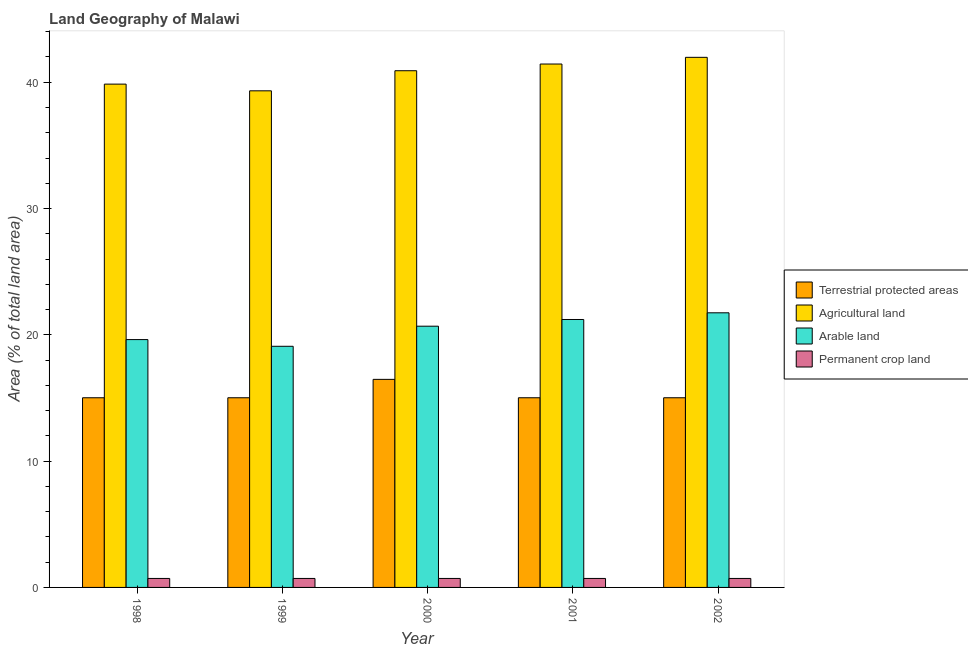How many different coloured bars are there?
Your response must be concise. 4. How many groups of bars are there?
Give a very brief answer. 5. Are the number of bars per tick equal to the number of legend labels?
Give a very brief answer. Yes. Are the number of bars on each tick of the X-axis equal?
Offer a terse response. Yes. How many bars are there on the 4th tick from the right?
Offer a very short reply. 4. What is the percentage of land under terrestrial protection in 1998?
Your answer should be compact. 15.02. Across all years, what is the maximum percentage of area under agricultural land?
Give a very brief answer. 41.97. Across all years, what is the minimum percentage of area under arable land?
Your answer should be compact. 19.09. In which year was the percentage of land under terrestrial protection maximum?
Your answer should be very brief. 2000. In which year was the percentage of area under agricultural land minimum?
Ensure brevity in your answer.  1999. What is the total percentage of area under permanent crop land in the graph?
Make the answer very short. 3.55. What is the difference between the percentage of area under agricultural land in 2000 and that in 2001?
Offer a terse response. -0.53. What is the difference between the percentage of area under permanent crop land in 1999 and the percentage of area under arable land in 2000?
Your answer should be compact. 0. What is the average percentage of land under terrestrial protection per year?
Offer a very short reply. 15.31. In how many years, is the percentage of area under agricultural land greater than 20 %?
Ensure brevity in your answer.  5. Is the difference between the percentage of land under terrestrial protection in 2000 and 2002 greater than the difference between the percentage of area under agricultural land in 2000 and 2002?
Provide a short and direct response. No. What is the difference between the highest and the second highest percentage of land under terrestrial protection?
Make the answer very short. 1.46. What is the difference between the highest and the lowest percentage of land under terrestrial protection?
Ensure brevity in your answer.  1.46. In how many years, is the percentage of land under terrestrial protection greater than the average percentage of land under terrestrial protection taken over all years?
Make the answer very short. 1. Is the sum of the percentage of area under agricultural land in 1998 and 2000 greater than the maximum percentage of land under terrestrial protection across all years?
Your answer should be very brief. Yes. What does the 4th bar from the left in 1999 represents?
Make the answer very short. Permanent crop land. What does the 4th bar from the right in 1998 represents?
Your answer should be very brief. Terrestrial protected areas. Are all the bars in the graph horizontal?
Ensure brevity in your answer.  No. Does the graph contain any zero values?
Offer a terse response. No. Where does the legend appear in the graph?
Offer a terse response. Center right. How many legend labels are there?
Your response must be concise. 4. How are the legend labels stacked?
Your answer should be compact. Vertical. What is the title of the graph?
Give a very brief answer. Land Geography of Malawi. Does "Other expenses" appear as one of the legend labels in the graph?
Ensure brevity in your answer.  No. What is the label or title of the Y-axis?
Keep it short and to the point. Area (% of total land area). What is the Area (% of total land area) in Terrestrial protected areas in 1998?
Provide a succinct answer. 15.02. What is the Area (% of total land area) in Agricultural land in 1998?
Give a very brief answer. 39.85. What is the Area (% of total land area) of Arable land in 1998?
Your response must be concise. 19.62. What is the Area (% of total land area) of Permanent crop land in 1998?
Your response must be concise. 0.71. What is the Area (% of total land area) in Terrestrial protected areas in 1999?
Provide a short and direct response. 15.02. What is the Area (% of total land area) in Agricultural land in 1999?
Provide a short and direct response. 39.32. What is the Area (% of total land area) of Arable land in 1999?
Your answer should be compact. 19.09. What is the Area (% of total land area) of Permanent crop land in 1999?
Offer a terse response. 0.71. What is the Area (% of total land area) of Terrestrial protected areas in 2000?
Give a very brief answer. 16.47. What is the Area (% of total land area) of Agricultural land in 2000?
Your answer should be very brief. 40.91. What is the Area (% of total land area) of Arable land in 2000?
Offer a very short reply. 20.68. What is the Area (% of total land area) of Permanent crop land in 2000?
Ensure brevity in your answer.  0.71. What is the Area (% of total land area) of Terrestrial protected areas in 2001?
Give a very brief answer. 15.02. What is the Area (% of total land area) of Agricultural land in 2001?
Your response must be concise. 41.44. What is the Area (% of total land area) in Arable land in 2001?
Offer a terse response. 21.21. What is the Area (% of total land area) in Permanent crop land in 2001?
Keep it short and to the point. 0.71. What is the Area (% of total land area) in Terrestrial protected areas in 2002?
Your response must be concise. 15.02. What is the Area (% of total land area) of Agricultural land in 2002?
Your answer should be compact. 41.97. What is the Area (% of total land area) in Arable land in 2002?
Your answer should be compact. 21.74. What is the Area (% of total land area) in Permanent crop land in 2002?
Provide a short and direct response. 0.71. Across all years, what is the maximum Area (% of total land area) in Terrestrial protected areas?
Keep it short and to the point. 16.47. Across all years, what is the maximum Area (% of total land area) in Agricultural land?
Give a very brief answer. 41.97. Across all years, what is the maximum Area (% of total land area) in Arable land?
Offer a very short reply. 21.74. Across all years, what is the maximum Area (% of total land area) in Permanent crop land?
Your answer should be compact. 0.71. Across all years, what is the minimum Area (% of total land area) of Terrestrial protected areas?
Your answer should be compact. 15.02. Across all years, what is the minimum Area (% of total land area) in Agricultural land?
Your answer should be compact. 39.32. Across all years, what is the minimum Area (% of total land area) in Arable land?
Keep it short and to the point. 19.09. Across all years, what is the minimum Area (% of total land area) of Permanent crop land?
Give a very brief answer. 0.71. What is the total Area (% of total land area) of Terrestrial protected areas in the graph?
Keep it short and to the point. 76.54. What is the total Area (% of total land area) in Agricultural land in the graph?
Provide a succinct answer. 203.49. What is the total Area (% of total land area) of Arable land in the graph?
Your answer should be compact. 102.35. What is the total Area (% of total land area) in Permanent crop land in the graph?
Your answer should be very brief. 3.55. What is the difference between the Area (% of total land area) in Terrestrial protected areas in 1998 and that in 1999?
Keep it short and to the point. 0. What is the difference between the Area (% of total land area) in Agricultural land in 1998 and that in 1999?
Offer a terse response. 0.53. What is the difference between the Area (% of total land area) in Arable land in 1998 and that in 1999?
Make the answer very short. 0.53. What is the difference between the Area (% of total land area) of Terrestrial protected areas in 1998 and that in 2000?
Your answer should be very brief. -1.46. What is the difference between the Area (% of total land area) of Agricultural land in 1998 and that in 2000?
Your answer should be compact. -1.06. What is the difference between the Area (% of total land area) of Arable land in 1998 and that in 2000?
Provide a succinct answer. -1.06. What is the difference between the Area (% of total land area) of Terrestrial protected areas in 1998 and that in 2001?
Offer a terse response. 0. What is the difference between the Area (% of total land area) in Agricultural land in 1998 and that in 2001?
Your response must be concise. -1.59. What is the difference between the Area (% of total land area) in Arable land in 1998 and that in 2001?
Offer a very short reply. -1.59. What is the difference between the Area (% of total land area) in Terrestrial protected areas in 1998 and that in 2002?
Ensure brevity in your answer.  0. What is the difference between the Area (% of total land area) in Agricultural land in 1998 and that in 2002?
Your answer should be very brief. -2.12. What is the difference between the Area (% of total land area) of Arable land in 1998 and that in 2002?
Your answer should be compact. -2.12. What is the difference between the Area (% of total land area) of Terrestrial protected areas in 1999 and that in 2000?
Provide a short and direct response. -1.46. What is the difference between the Area (% of total land area) in Agricultural land in 1999 and that in 2000?
Make the answer very short. -1.59. What is the difference between the Area (% of total land area) in Arable land in 1999 and that in 2000?
Your answer should be very brief. -1.59. What is the difference between the Area (% of total land area) of Permanent crop land in 1999 and that in 2000?
Provide a succinct answer. 0. What is the difference between the Area (% of total land area) in Terrestrial protected areas in 1999 and that in 2001?
Your answer should be very brief. 0. What is the difference between the Area (% of total land area) of Agricultural land in 1999 and that in 2001?
Your answer should be compact. -2.12. What is the difference between the Area (% of total land area) of Arable land in 1999 and that in 2001?
Make the answer very short. -2.12. What is the difference between the Area (% of total land area) of Terrestrial protected areas in 1999 and that in 2002?
Give a very brief answer. 0. What is the difference between the Area (% of total land area) in Agricultural land in 1999 and that in 2002?
Ensure brevity in your answer.  -2.65. What is the difference between the Area (% of total land area) in Arable land in 1999 and that in 2002?
Provide a succinct answer. -2.65. What is the difference between the Area (% of total land area) of Permanent crop land in 1999 and that in 2002?
Give a very brief answer. 0. What is the difference between the Area (% of total land area) in Terrestrial protected areas in 2000 and that in 2001?
Give a very brief answer. 1.46. What is the difference between the Area (% of total land area) of Agricultural land in 2000 and that in 2001?
Offer a very short reply. -0.53. What is the difference between the Area (% of total land area) in Arable land in 2000 and that in 2001?
Make the answer very short. -0.53. What is the difference between the Area (% of total land area) in Permanent crop land in 2000 and that in 2001?
Keep it short and to the point. 0. What is the difference between the Area (% of total land area) of Terrestrial protected areas in 2000 and that in 2002?
Make the answer very short. 1.46. What is the difference between the Area (% of total land area) of Agricultural land in 2000 and that in 2002?
Your response must be concise. -1.06. What is the difference between the Area (% of total land area) in Arable land in 2000 and that in 2002?
Make the answer very short. -1.06. What is the difference between the Area (% of total land area) in Permanent crop land in 2000 and that in 2002?
Provide a succinct answer. 0. What is the difference between the Area (% of total land area) in Agricultural land in 2001 and that in 2002?
Give a very brief answer. -0.53. What is the difference between the Area (% of total land area) in Arable land in 2001 and that in 2002?
Offer a very short reply. -0.53. What is the difference between the Area (% of total land area) in Permanent crop land in 2001 and that in 2002?
Offer a terse response. 0. What is the difference between the Area (% of total land area) in Terrestrial protected areas in 1998 and the Area (% of total land area) in Agricultural land in 1999?
Provide a short and direct response. -24.3. What is the difference between the Area (% of total land area) of Terrestrial protected areas in 1998 and the Area (% of total land area) of Arable land in 1999?
Keep it short and to the point. -4.07. What is the difference between the Area (% of total land area) of Terrestrial protected areas in 1998 and the Area (% of total land area) of Permanent crop land in 1999?
Your response must be concise. 14.31. What is the difference between the Area (% of total land area) of Agricultural land in 1998 and the Area (% of total land area) of Arable land in 1999?
Offer a very short reply. 20.76. What is the difference between the Area (% of total land area) in Agricultural land in 1998 and the Area (% of total land area) in Permanent crop land in 1999?
Give a very brief answer. 39.14. What is the difference between the Area (% of total land area) of Arable land in 1998 and the Area (% of total land area) of Permanent crop land in 1999?
Provide a succinct answer. 18.91. What is the difference between the Area (% of total land area) of Terrestrial protected areas in 1998 and the Area (% of total land area) of Agricultural land in 2000?
Your answer should be compact. -25.89. What is the difference between the Area (% of total land area) in Terrestrial protected areas in 1998 and the Area (% of total land area) in Arable land in 2000?
Offer a very short reply. -5.67. What is the difference between the Area (% of total land area) in Terrestrial protected areas in 1998 and the Area (% of total land area) in Permanent crop land in 2000?
Provide a short and direct response. 14.31. What is the difference between the Area (% of total land area) of Agricultural land in 1998 and the Area (% of total land area) of Arable land in 2000?
Provide a short and direct response. 19.17. What is the difference between the Area (% of total land area) in Agricultural land in 1998 and the Area (% of total land area) in Permanent crop land in 2000?
Give a very brief answer. 39.14. What is the difference between the Area (% of total land area) of Arable land in 1998 and the Area (% of total land area) of Permanent crop land in 2000?
Keep it short and to the point. 18.91. What is the difference between the Area (% of total land area) in Terrestrial protected areas in 1998 and the Area (% of total land area) in Agricultural land in 2001?
Offer a very short reply. -26.42. What is the difference between the Area (% of total land area) in Terrestrial protected areas in 1998 and the Area (% of total land area) in Arable land in 2001?
Keep it short and to the point. -6.2. What is the difference between the Area (% of total land area) in Terrestrial protected areas in 1998 and the Area (% of total land area) in Permanent crop land in 2001?
Provide a short and direct response. 14.31. What is the difference between the Area (% of total land area) in Agricultural land in 1998 and the Area (% of total land area) in Arable land in 2001?
Offer a very short reply. 18.64. What is the difference between the Area (% of total land area) in Agricultural land in 1998 and the Area (% of total land area) in Permanent crop land in 2001?
Ensure brevity in your answer.  39.14. What is the difference between the Area (% of total land area) of Arable land in 1998 and the Area (% of total land area) of Permanent crop land in 2001?
Give a very brief answer. 18.91. What is the difference between the Area (% of total land area) of Terrestrial protected areas in 1998 and the Area (% of total land area) of Agricultural land in 2002?
Your answer should be compact. -26.95. What is the difference between the Area (% of total land area) in Terrestrial protected areas in 1998 and the Area (% of total land area) in Arable land in 2002?
Your answer should be very brief. -6.73. What is the difference between the Area (% of total land area) in Terrestrial protected areas in 1998 and the Area (% of total land area) in Permanent crop land in 2002?
Your response must be concise. 14.31. What is the difference between the Area (% of total land area) of Agricultural land in 1998 and the Area (% of total land area) of Arable land in 2002?
Your answer should be very brief. 18.11. What is the difference between the Area (% of total land area) in Agricultural land in 1998 and the Area (% of total land area) in Permanent crop land in 2002?
Offer a terse response. 39.14. What is the difference between the Area (% of total land area) in Arable land in 1998 and the Area (% of total land area) in Permanent crop land in 2002?
Give a very brief answer. 18.91. What is the difference between the Area (% of total land area) of Terrestrial protected areas in 1999 and the Area (% of total land area) of Agricultural land in 2000?
Your answer should be compact. -25.89. What is the difference between the Area (% of total land area) of Terrestrial protected areas in 1999 and the Area (% of total land area) of Arable land in 2000?
Offer a very short reply. -5.67. What is the difference between the Area (% of total land area) in Terrestrial protected areas in 1999 and the Area (% of total land area) in Permanent crop land in 2000?
Keep it short and to the point. 14.31. What is the difference between the Area (% of total land area) in Agricultural land in 1999 and the Area (% of total land area) in Arable land in 2000?
Give a very brief answer. 18.64. What is the difference between the Area (% of total land area) in Agricultural land in 1999 and the Area (% of total land area) in Permanent crop land in 2000?
Make the answer very short. 38.61. What is the difference between the Area (% of total land area) in Arable land in 1999 and the Area (% of total land area) in Permanent crop land in 2000?
Ensure brevity in your answer.  18.38. What is the difference between the Area (% of total land area) of Terrestrial protected areas in 1999 and the Area (% of total land area) of Agricultural land in 2001?
Offer a terse response. -26.42. What is the difference between the Area (% of total land area) in Terrestrial protected areas in 1999 and the Area (% of total land area) in Arable land in 2001?
Your response must be concise. -6.2. What is the difference between the Area (% of total land area) in Terrestrial protected areas in 1999 and the Area (% of total land area) in Permanent crop land in 2001?
Offer a terse response. 14.31. What is the difference between the Area (% of total land area) of Agricultural land in 1999 and the Area (% of total land area) of Arable land in 2001?
Give a very brief answer. 18.11. What is the difference between the Area (% of total land area) of Agricultural land in 1999 and the Area (% of total land area) of Permanent crop land in 2001?
Give a very brief answer. 38.61. What is the difference between the Area (% of total land area) of Arable land in 1999 and the Area (% of total land area) of Permanent crop land in 2001?
Provide a short and direct response. 18.38. What is the difference between the Area (% of total land area) of Terrestrial protected areas in 1999 and the Area (% of total land area) of Agricultural land in 2002?
Make the answer very short. -26.95. What is the difference between the Area (% of total land area) of Terrestrial protected areas in 1999 and the Area (% of total land area) of Arable land in 2002?
Your response must be concise. -6.73. What is the difference between the Area (% of total land area) of Terrestrial protected areas in 1999 and the Area (% of total land area) of Permanent crop land in 2002?
Keep it short and to the point. 14.31. What is the difference between the Area (% of total land area) in Agricultural land in 1999 and the Area (% of total land area) in Arable land in 2002?
Make the answer very short. 17.58. What is the difference between the Area (% of total land area) in Agricultural land in 1999 and the Area (% of total land area) in Permanent crop land in 2002?
Give a very brief answer. 38.61. What is the difference between the Area (% of total land area) of Arable land in 1999 and the Area (% of total land area) of Permanent crop land in 2002?
Provide a succinct answer. 18.38. What is the difference between the Area (% of total land area) in Terrestrial protected areas in 2000 and the Area (% of total land area) in Agricultural land in 2001?
Your answer should be very brief. -24.97. What is the difference between the Area (% of total land area) in Terrestrial protected areas in 2000 and the Area (% of total land area) in Arable land in 2001?
Provide a short and direct response. -4.74. What is the difference between the Area (% of total land area) in Terrestrial protected areas in 2000 and the Area (% of total land area) in Permanent crop land in 2001?
Your answer should be very brief. 15.76. What is the difference between the Area (% of total land area) in Agricultural land in 2000 and the Area (% of total land area) in Arable land in 2001?
Your answer should be very brief. 19.7. What is the difference between the Area (% of total land area) of Agricultural land in 2000 and the Area (% of total land area) of Permanent crop land in 2001?
Make the answer very short. 40.2. What is the difference between the Area (% of total land area) of Arable land in 2000 and the Area (% of total land area) of Permanent crop land in 2001?
Your response must be concise. 19.97. What is the difference between the Area (% of total land area) of Terrestrial protected areas in 2000 and the Area (% of total land area) of Agricultural land in 2002?
Offer a terse response. -25.5. What is the difference between the Area (% of total land area) of Terrestrial protected areas in 2000 and the Area (% of total land area) of Arable land in 2002?
Your answer should be very brief. -5.27. What is the difference between the Area (% of total land area) of Terrestrial protected areas in 2000 and the Area (% of total land area) of Permanent crop land in 2002?
Offer a very short reply. 15.76. What is the difference between the Area (% of total land area) of Agricultural land in 2000 and the Area (% of total land area) of Arable land in 2002?
Your answer should be compact. 19.17. What is the difference between the Area (% of total land area) in Agricultural land in 2000 and the Area (% of total land area) in Permanent crop land in 2002?
Provide a succinct answer. 40.2. What is the difference between the Area (% of total land area) of Arable land in 2000 and the Area (% of total land area) of Permanent crop land in 2002?
Offer a terse response. 19.97. What is the difference between the Area (% of total land area) in Terrestrial protected areas in 2001 and the Area (% of total land area) in Agricultural land in 2002?
Your answer should be very brief. -26.95. What is the difference between the Area (% of total land area) in Terrestrial protected areas in 2001 and the Area (% of total land area) in Arable land in 2002?
Keep it short and to the point. -6.73. What is the difference between the Area (% of total land area) of Terrestrial protected areas in 2001 and the Area (% of total land area) of Permanent crop land in 2002?
Give a very brief answer. 14.31. What is the difference between the Area (% of total land area) in Agricultural land in 2001 and the Area (% of total land area) in Arable land in 2002?
Your answer should be very brief. 19.7. What is the difference between the Area (% of total land area) in Agricultural land in 2001 and the Area (% of total land area) in Permanent crop land in 2002?
Offer a terse response. 40.73. What is the difference between the Area (% of total land area) in Arable land in 2001 and the Area (% of total land area) in Permanent crop land in 2002?
Your answer should be compact. 20.5. What is the average Area (% of total land area) of Terrestrial protected areas per year?
Provide a short and direct response. 15.31. What is the average Area (% of total land area) in Agricultural land per year?
Offer a terse response. 40.7. What is the average Area (% of total land area) in Arable land per year?
Give a very brief answer. 20.47. What is the average Area (% of total land area) in Permanent crop land per year?
Provide a short and direct response. 0.71. In the year 1998, what is the difference between the Area (% of total land area) of Terrestrial protected areas and Area (% of total land area) of Agricultural land?
Make the answer very short. -24.83. In the year 1998, what is the difference between the Area (% of total land area) of Terrestrial protected areas and Area (% of total land area) of Arable land?
Make the answer very short. -4.6. In the year 1998, what is the difference between the Area (% of total land area) of Terrestrial protected areas and Area (% of total land area) of Permanent crop land?
Provide a short and direct response. 14.31. In the year 1998, what is the difference between the Area (% of total land area) in Agricultural land and Area (% of total land area) in Arable land?
Make the answer very short. 20.23. In the year 1998, what is the difference between the Area (% of total land area) of Agricultural land and Area (% of total land area) of Permanent crop land?
Offer a terse response. 39.14. In the year 1998, what is the difference between the Area (% of total land area) of Arable land and Area (% of total land area) of Permanent crop land?
Your answer should be very brief. 18.91. In the year 1999, what is the difference between the Area (% of total land area) in Terrestrial protected areas and Area (% of total land area) in Agricultural land?
Offer a very short reply. -24.3. In the year 1999, what is the difference between the Area (% of total land area) in Terrestrial protected areas and Area (% of total land area) in Arable land?
Ensure brevity in your answer.  -4.07. In the year 1999, what is the difference between the Area (% of total land area) of Terrestrial protected areas and Area (% of total land area) of Permanent crop land?
Make the answer very short. 14.31. In the year 1999, what is the difference between the Area (% of total land area) of Agricultural land and Area (% of total land area) of Arable land?
Give a very brief answer. 20.23. In the year 1999, what is the difference between the Area (% of total land area) in Agricultural land and Area (% of total land area) in Permanent crop land?
Your answer should be compact. 38.61. In the year 1999, what is the difference between the Area (% of total land area) in Arable land and Area (% of total land area) in Permanent crop land?
Your answer should be compact. 18.38. In the year 2000, what is the difference between the Area (% of total land area) in Terrestrial protected areas and Area (% of total land area) in Agricultural land?
Make the answer very short. -24.44. In the year 2000, what is the difference between the Area (% of total land area) in Terrestrial protected areas and Area (% of total land area) in Arable land?
Make the answer very short. -4.21. In the year 2000, what is the difference between the Area (% of total land area) of Terrestrial protected areas and Area (% of total land area) of Permanent crop land?
Provide a succinct answer. 15.76. In the year 2000, what is the difference between the Area (% of total land area) in Agricultural land and Area (% of total land area) in Arable land?
Your response must be concise. 20.23. In the year 2000, what is the difference between the Area (% of total land area) of Agricultural land and Area (% of total land area) of Permanent crop land?
Give a very brief answer. 40.2. In the year 2000, what is the difference between the Area (% of total land area) in Arable land and Area (% of total land area) in Permanent crop land?
Offer a terse response. 19.97. In the year 2001, what is the difference between the Area (% of total land area) of Terrestrial protected areas and Area (% of total land area) of Agricultural land?
Your answer should be very brief. -26.42. In the year 2001, what is the difference between the Area (% of total land area) in Terrestrial protected areas and Area (% of total land area) in Arable land?
Make the answer very short. -6.2. In the year 2001, what is the difference between the Area (% of total land area) in Terrestrial protected areas and Area (% of total land area) in Permanent crop land?
Offer a terse response. 14.31. In the year 2001, what is the difference between the Area (% of total land area) of Agricultural land and Area (% of total land area) of Arable land?
Provide a short and direct response. 20.23. In the year 2001, what is the difference between the Area (% of total land area) of Agricultural land and Area (% of total land area) of Permanent crop land?
Your answer should be compact. 40.73. In the year 2001, what is the difference between the Area (% of total land area) of Arable land and Area (% of total land area) of Permanent crop land?
Provide a succinct answer. 20.5. In the year 2002, what is the difference between the Area (% of total land area) of Terrestrial protected areas and Area (% of total land area) of Agricultural land?
Ensure brevity in your answer.  -26.95. In the year 2002, what is the difference between the Area (% of total land area) of Terrestrial protected areas and Area (% of total land area) of Arable land?
Provide a short and direct response. -6.73. In the year 2002, what is the difference between the Area (% of total land area) of Terrestrial protected areas and Area (% of total land area) of Permanent crop land?
Give a very brief answer. 14.31. In the year 2002, what is the difference between the Area (% of total land area) of Agricultural land and Area (% of total land area) of Arable land?
Your answer should be compact. 20.23. In the year 2002, what is the difference between the Area (% of total land area) in Agricultural land and Area (% of total land area) in Permanent crop land?
Make the answer very short. 41.26. In the year 2002, what is the difference between the Area (% of total land area) of Arable land and Area (% of total land area) of Permanent crop land?
Your response must be concise. 21.03. What is the ratio of the Area (% of total land area) in Terrestrial protected areas in 1998 to that in 1999?
Your response must be concise. 1. What is the ratio of the Area (% of total land area) in Agricultural land in 1998 to that in 1999?
Your answer should be compact. 1.01. What is the ratio of the Area (% of total land area) of Arable land in 1998 to that in 1999?
Keep it short and to the point. 1.03. What is the ratio of the Area (% of total land area) of Terrestrial protected areas in 1998 to that in 2000?
Offer a very short reply. 0.91. What is the ratio of the Area (% of total land area) of Agricultural land in 1998 to that in 2000?
Offer a terse response. 0.97. What is the ratio of the Area (% of total land area) of Arable land in 1998 to that in 2000?
Your answer should be compact. 0.95. What is the ratio of the Area (% of total land area) of Permanent crop land in 1998 to that in 2000?
Your answer should be very brief. 1. What is the ratio of the Area (% of total land area) in Terrestrial protected areas in 1998 to that in 2001?
Offer a terse response. 1. What is the ratio of the Area (% of total land area) in Agricultural land in 1998 to that in 2001?
Your answer should be compact. 0.96. What is the ratio of the Area (% of total land area) in Arable land in 1998 to that in 2001?
Ensure brevity in your answer.  0.93. What is the ratio of the Area (% of total land area) of Permanent crop land in 1998 to that in 2001?
Provide a short and direct response. 1. What is the ratio of the Area (% of total land area) of Agricultural land in 1998 to that in 2002?
Your response must be concise. 0.95. What is the ratio of the Area (% of total land area) in Arable land in 1998 to that in 2002?
Your answer should be compact. 0.9. What is the ratio of the Area (% of total land area) in Permanent crop land in 1998 to that in 2002?
Your response must be concise. 1. What is the ratio of the Area (% of total land area) of Terrestrial protected areas in 1999 to that in 2000?
Provide a short and direct response. 0.91. What is the ratio of the Area (% of total land area) in Agricultural land in 1999 to that in 2000?
Your answer should be very brief. 0.96. What is the ratio of the Area (% of total land area) of Permanent crop land in 1999 to that in 2000?
Offer a terse response. 1. What is the ratio of the Area (% of total land area) of Terrestrial protected areas in 1999 to that in 2001?
Give a very brief answer. 1. What is the ratio of the Area (% of total land area) of Agricultural land in 1999 to that in 2001?
Ensure brevity in your answer.  0.95. What is the ratio of the Area (% of total land area) in Terrestrial protected areas in 1999 to that in 2002?
Your answer should be compact. 1. What is the ratio of the Area (% of total land area) of Agricultural land in 1999 to that in 2002?
Offer a very short reply. 0.94. What is the ratio of the Area (% of total land area) of Arable land in 1999 to that in 2002?
Ensure brevity in your answer.  0.88. What is the ratio of the Area (% of total land area) of Terrestrial protected areas in 2000 to that in 2001?
Your answer should be compact. 1.1. What is the ratio of the Area (% of total land area) of Agricultural land in 2000 to that in 2001?
Provide a short and direct response. 0.99. What is the ratio of the Area (% of total land area) of Arable land in 2000 to that in 2001?
Provide a succinct answer. 0.97. What is the ratio of the Area (% of total land area) of Terrestrial protected areas in 2000 to that in 2002?
Your response must be concise. 1.1. What is the ratio of the Area (% of total land area) of Agricultural land in 2000 to that in 2002?
Keep it short and to the point. 0.97. What is the ratio of the Area (% of total land area) of Arable land in 2000 to that in 2002?
Offer a very short reply. 0.95. What is the ratio of the Area (% of total land area) of Permanent crop land in 2000 to that in 2002?
Your answer should be compact. 1. What is the ratio of the Area (% of total land area) of Agricultural land in 2001 to that in 2002?
Provide a short and direct response. 0.99. What is the ratio of the Area (% of total land area) in Arable land in 2001 to that in 2002?
Keep it short and to the point. 0.98. What is the difference between the highest and the second highest Area (% of total land area) in Terrestrial protected areas?
Offer a very short reply. 1.46. What is the difference between the highest and the second highest Area (% of total land area) of Agricultural land?
Offer a terse response. 0.53. What is the difference between the highest and the second highest Area (% of total land area) in Arable land?
Provide a short and direct response. 0.53. What is the difference between the highest and the lowest Area (% of total land area) of Terrestrial protected areas?
Ensure brevity in your answer.  1.46. What is the difference between the highest and the lowest Area (% of total land area) in Agricultural land?
Ensure brevity in your answer.  2.65. What is the difference between the highest and the lowest Area (% of total land area) in Arable land?
Your response must be concise. 2.65. 